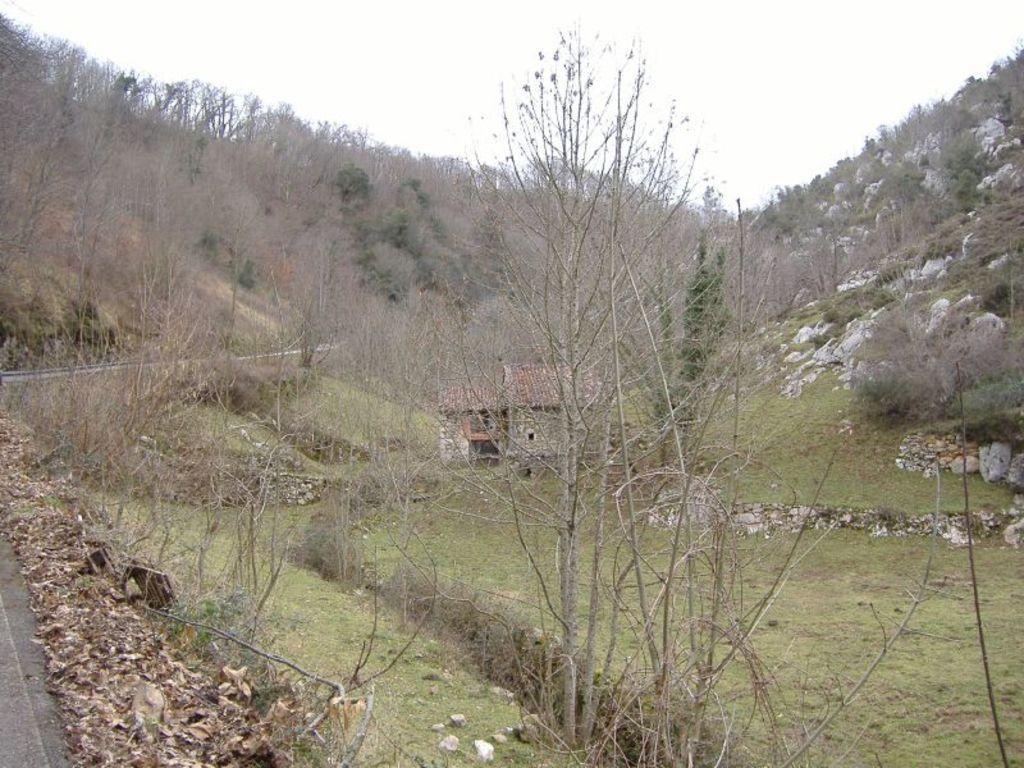How would you summarize this image in a sentence or two? In this picture I can see the house. I can see the road on the left side. I can see trees. I can see green grass. I can see clouds in the sky. 